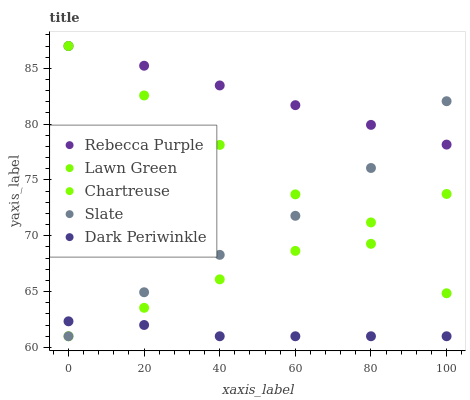Does Dark Periwinkle have the minimum area under the curve?
Answer yes or no. Yes. Does Rebecca Purple have the maximum area under the curve?
Answer yes or no. Yes. Does Chartreuse have the minimum area under the curve?
Answer yes or no. No. Does Chartreuse have the maximum area under the curve?
Answer yes or no. No. Is Lawn Green the smoothest?
Answer yes or no. Yes. Is Slate the roughest?
Answer yes or no. Yes. Is Slate the smoothest?
Answer yes or no. No. Is Chartreuse the roughest?
Answer yes or no. No. Does Chartreuse have the lowest value?
Answer yes or no. Yes. Does Rebecca Purple have the lowest value?
Answer yes or no. No. Does Rebecca Purple have the highest value?
Answer yes or no. Yes. Does Chartreuse have the highest value?
Answer yes or no. No. Is Dark Periwinkle less than Lawn Green?
Answer yes or no. Yes. Is Rebecca Purple greater than Chartreuse?
Answer yes or no. Yes. Does Dark Periwinkle intersect Chartreuse?
Answer yes or no. Yes. Is Dark Periwinkle less than Chartreuse?
Answer yes or no. No. Is Dark Periwinkle greater than Chartreuse?
Answer yes or no. No. Does Dark Periwinkle intersect Lawn Green?
Answer yes or no. No. 